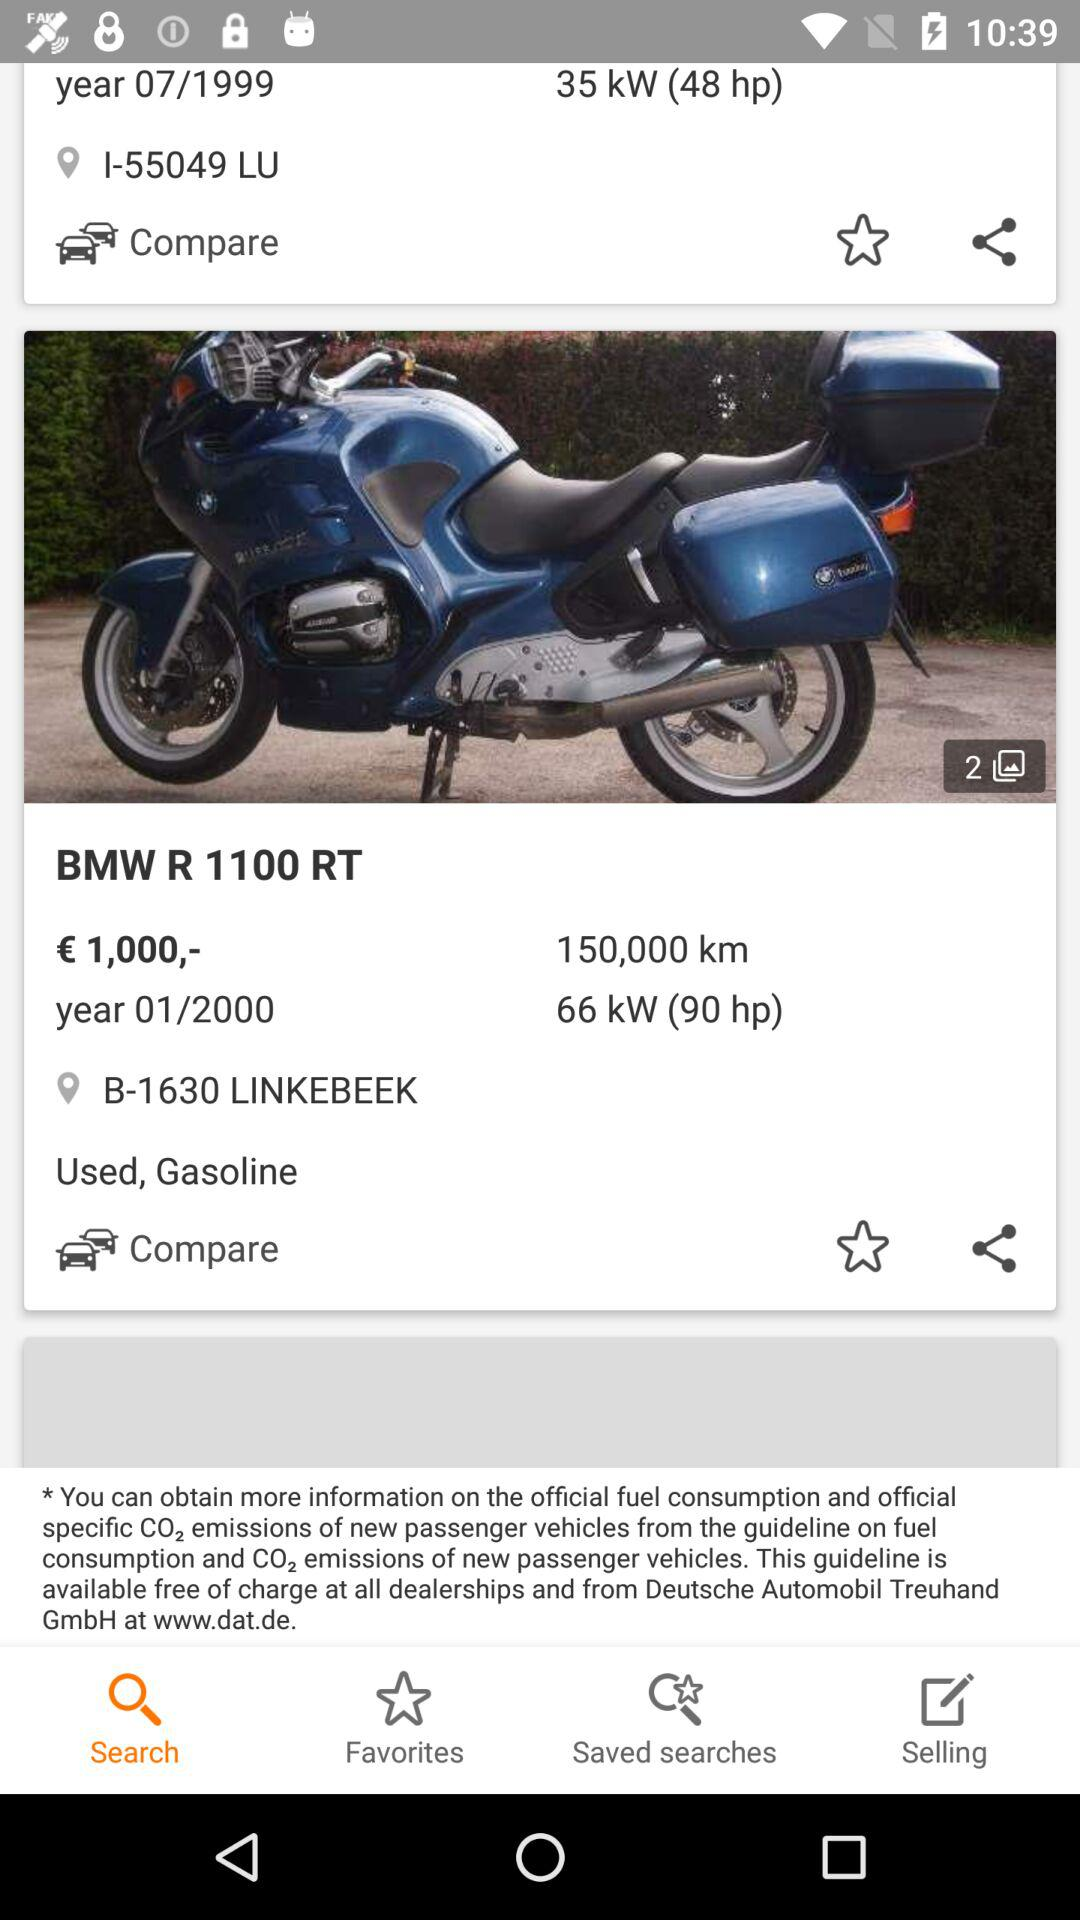What is the price of "BMW R 1100 RT"? The price is 1,000 euros. 